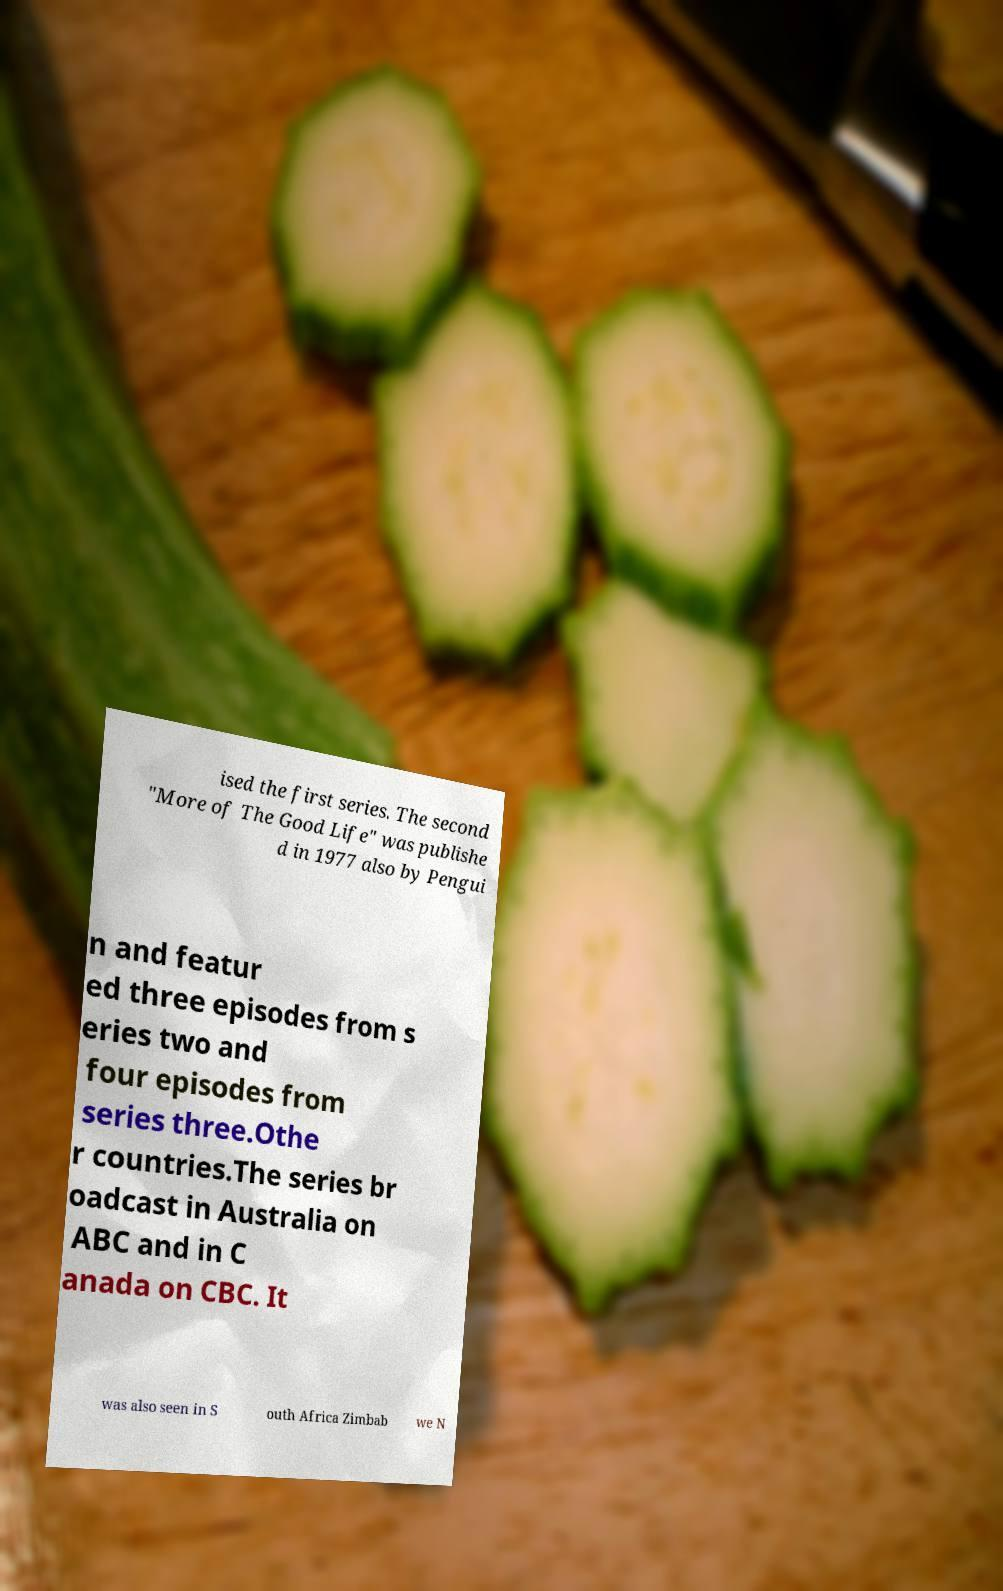Please read and relay the text visible in this image. What does it say? ised the first series. The second "More of The Good Life" was publishe d in 1977 also by Pengui n and featur ed three episodes from s eries two and four episodes from series three.Othe r countries.The series br oadcast in Australia on ABC and in C anada on CBC. It was also seen in S outh Africa Zimbab we N 